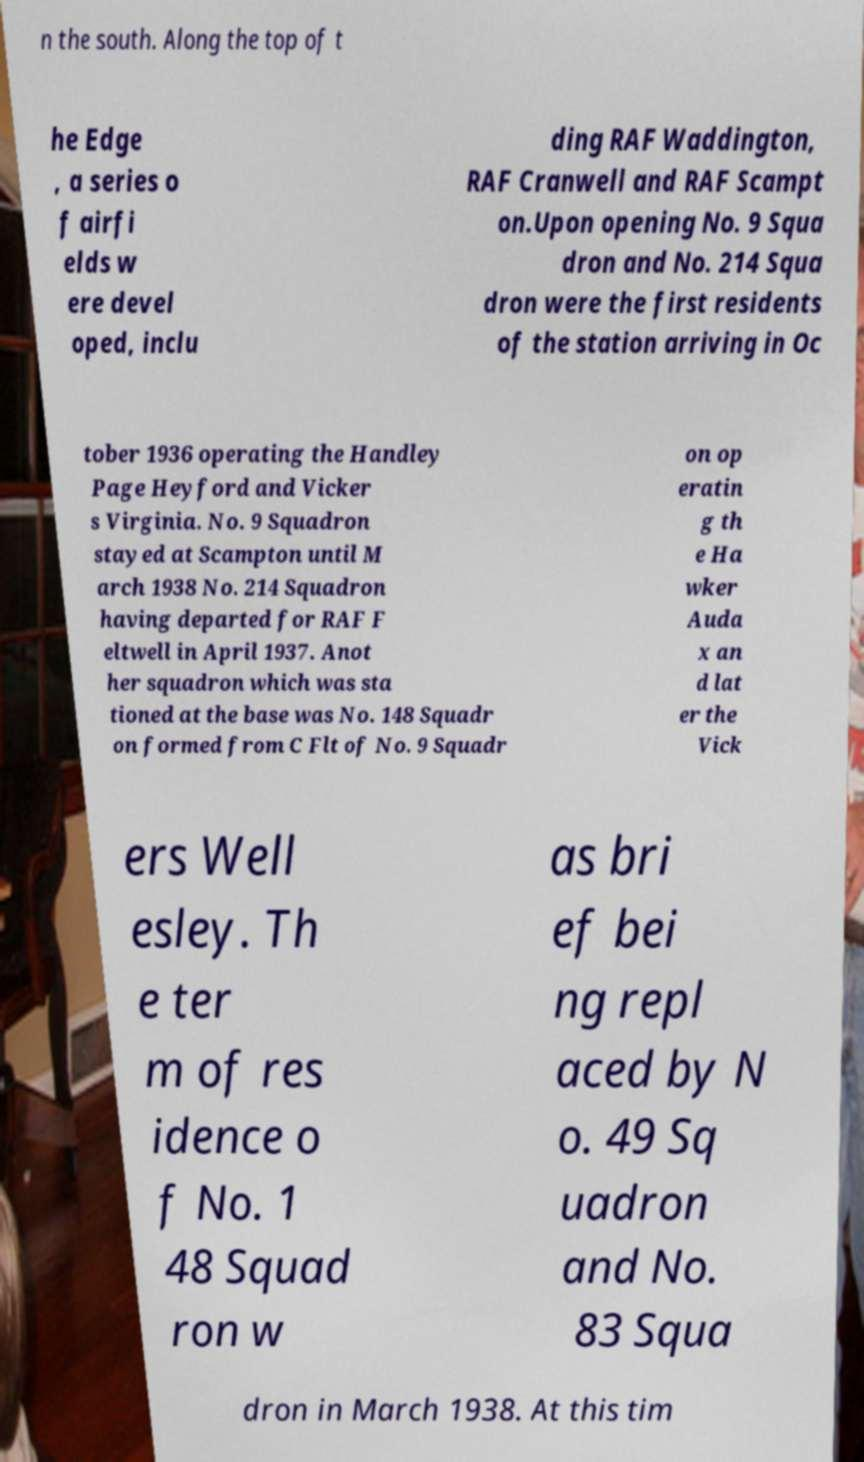What messages or text are displayed in this image? I need them in a readable, typed format. n the south. Along the top of t he Edge , a series o f airfi elds w ere devel oped, inclu ding RAF Waddington, RAF Cranwell and RAF Scampt on.Upon opening No. 9 Squa dron and No. 214 Squa dron were the first residents of the station arriving in Oc tober 1936 operating the Handley Page Heyford and Vicker s Virginia. No. 9 Squadron stayed at Scampton until M arch 1938 No. 214 Squadron having departed for RAF F eltwell in April 1937. Anot her squadron which was sta tioned at the base was No. 148 Squadr on formed from C Flt of No. 9 Squadr on op eratin g th e Ha wker Auda x an d lat er the Vick ers Well esley. Th e ter m of res idence o f No. 1 48 Squad ron w as bri ef bei ng repl aced by N o. 49 Sq uadron and No. 83 Squa dron in March 1938. At this tim 